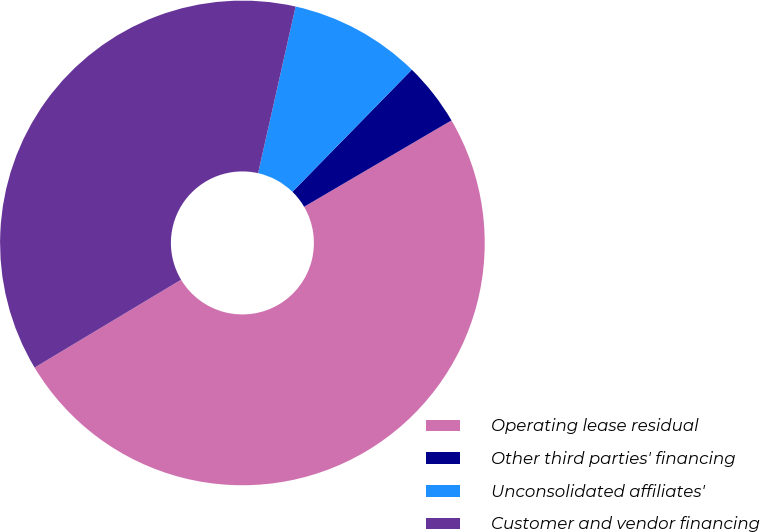Convert chart to OTSL. <chart><loc_0><loc_0><loc_500><loc_500><pie_chart><fcel>Operating lease residual<fcel>Other third parties' financing<fcel>Unconsolidated affiliates'<fcel>Customer and vendor financing<nl><fcel>49.84%<fcel>4.24%<fcel>8.8%<fcel>37.12%<nl></chart> 